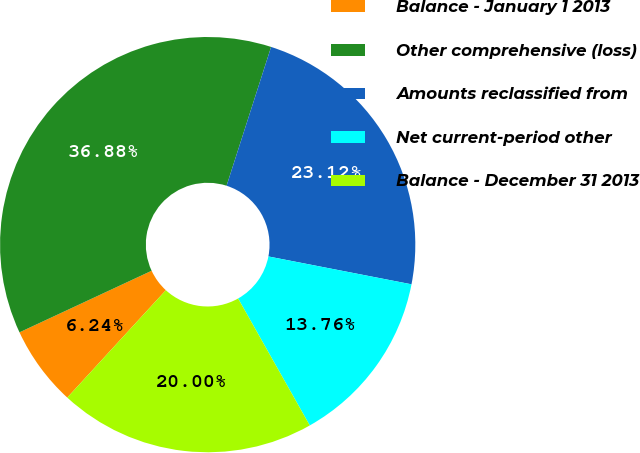<chart> <loc_0><loc_0><loc_500><loc_500><pie_chart><fcel>Balance - January 1 2013<fcel>Other comprehensive (loss)<fcel>Amounts reclassified from<fcel>Net current-period other<fcel>Balance - December 31 2013<nl><fcel>6.24%<fcel>36.88%<fcel>23.12%<fcel>13.76%<fcel>20.0%<nl></chart> 